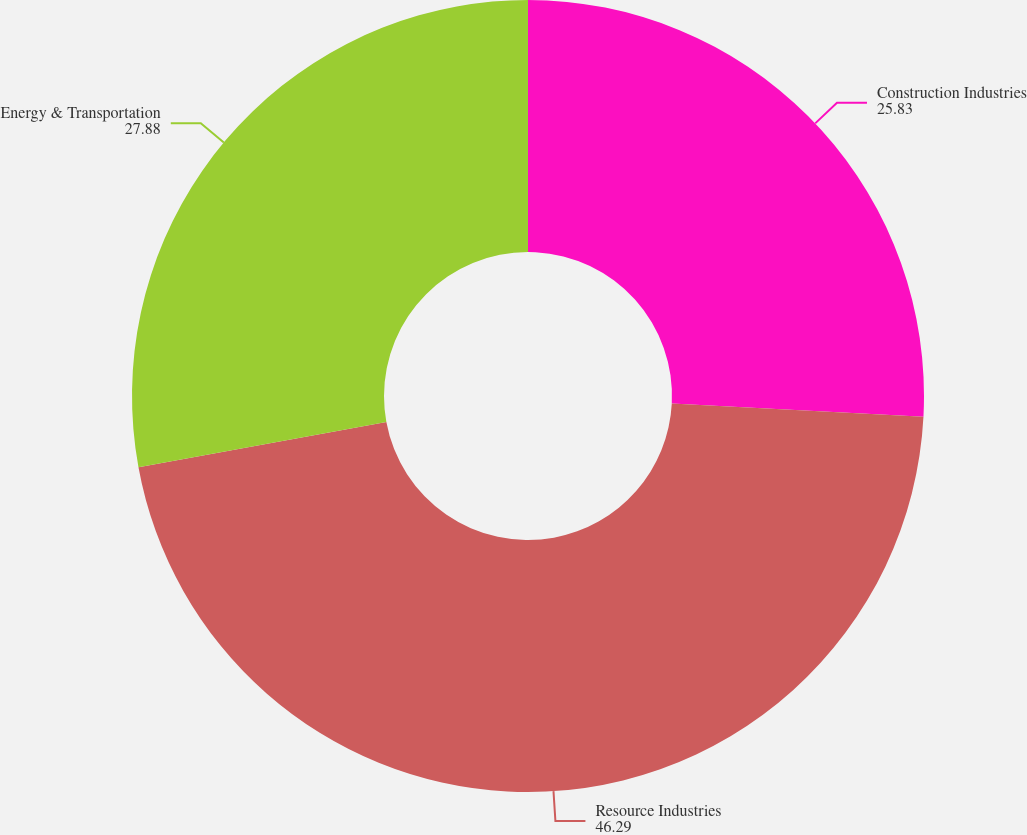<chart> <loc_0><loc_0><loc_500><loc_500><pie_chart><fcel>Construction Industries<fcel>Resource Industries<fcel>Energy & Transportation<nl><fcel>25.83%<fcel>46.29%<fcel>27.88%<nl></chart> 